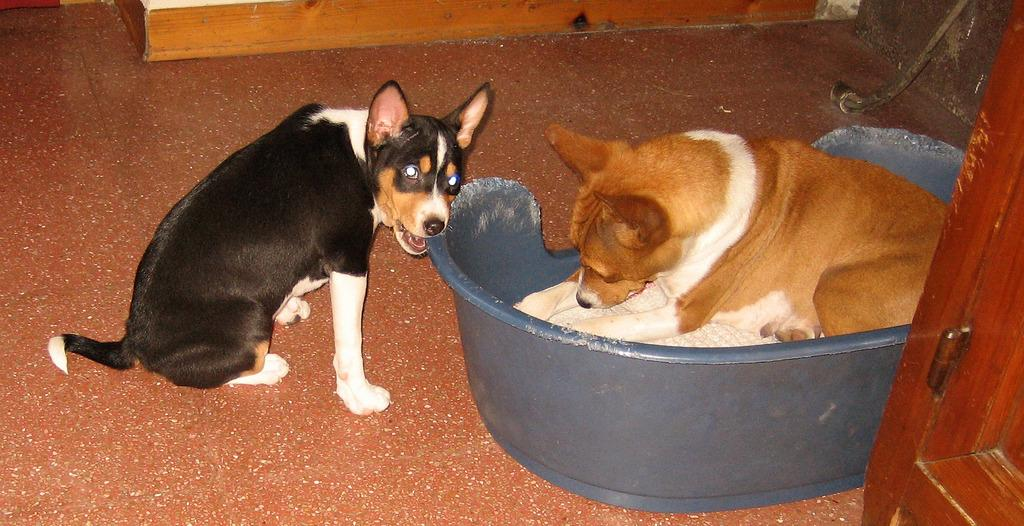How many dogs are in the image? There are two dogs in the image. What are the positions of the dogs in the image? One dog is sitting on the floor, and the other dog is sitting inside a tub. Can you describe any other objects present in the image? The provided facts do not mention any other objects in the image. What type of ear is the dog wearing in the image? There is no dog wearing an ear in the image. What achievements has the dog accomplished, as seen in the image? The provided facts do not mention any achievements by the dogs in the image. What is the cause of death for the dog in the image? There is no indication of death or any deceased dog in the image. 